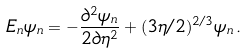<formula> <loc_0><loc_0><loc_500><loc_500>E _ { n } \psi _ { n } = - \frac { \partial ^ { 2 } \psi _ { n } } { 2 \partial \eta ^ { 2 } } + ( 3 \eta / 2 ) ^ { 2 / 3 } \psi _ { n } \, .</formula> 